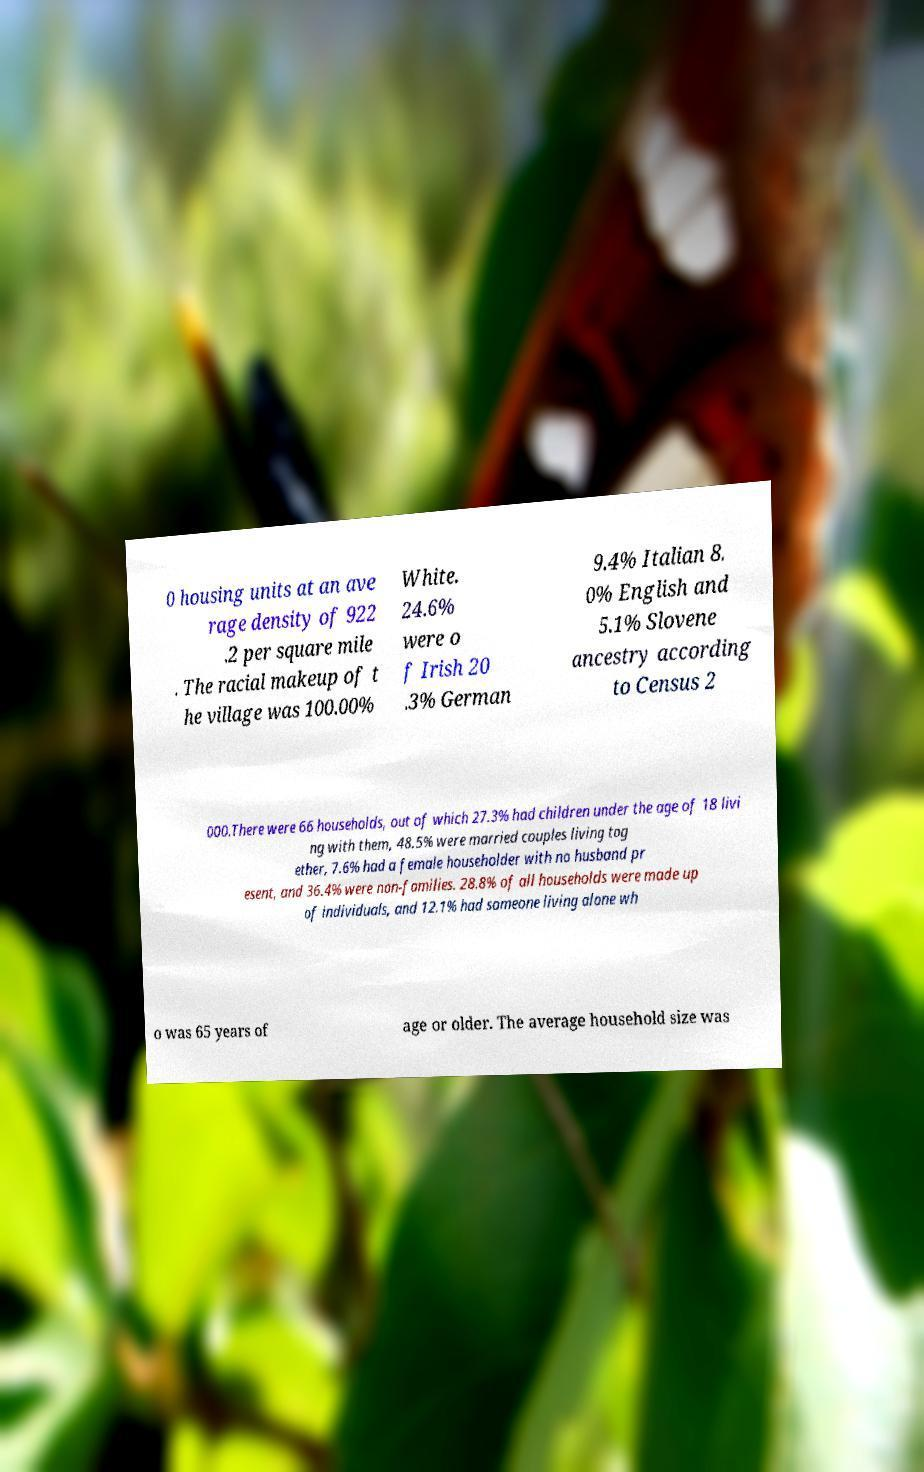For documentation purposes, I need the text within this image transcribed. Could you provide that? 0 housing units at an ave rage density of 922 .2 per square mile . The racial makeup of t he village was 100.00% White. 24.6% were o f Irish 20 .3% German 9.4% Italian 8. 0% English and 5.1% Slovene ancestry according to Census 2 000.There were 66 households, out of which 27.3% had children under the age of 18 livi ng with them, 48.5% were married couples living tog ether, 7.6% had a female householder with no husband pr esent, and 36.4% were non-families. 28.8% of all households were made up of individuals, and 12.1% had someone living alone wh o was 65 years of age or older. The average household size was 